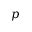<formula> <loc_0><loc_0><loc_500><loc_500>p</formula> 